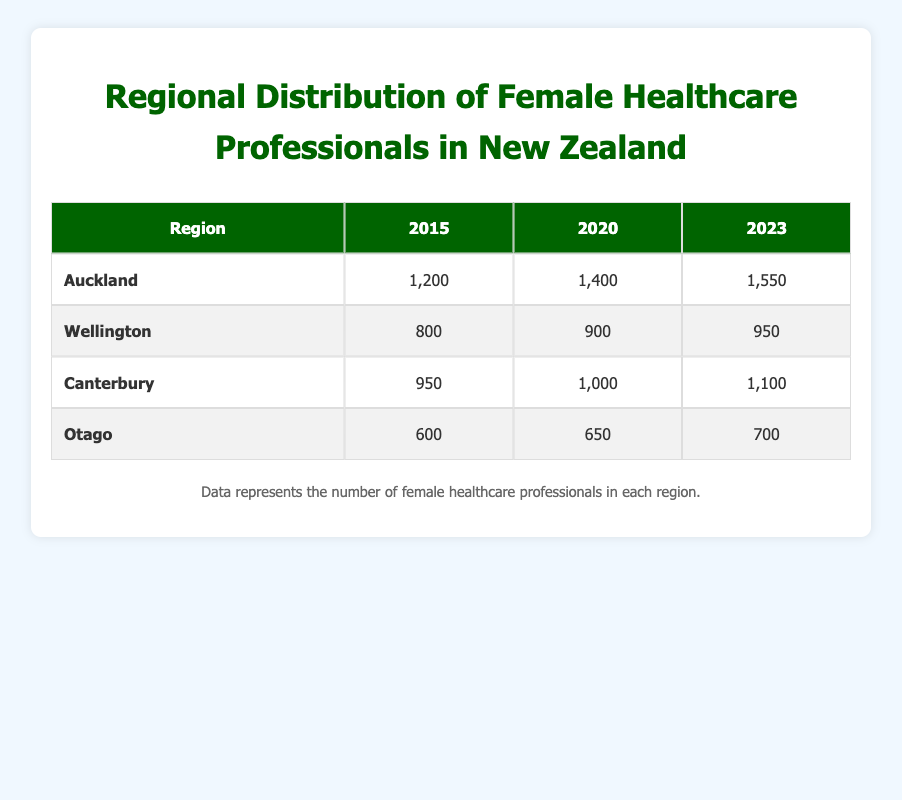What is the number of female healthcare professionals in Auckland in 2020? According to the table, the number of female healthcare professionals in Auckland for the year 2020 is listed under the column for that year. It shows a value of 1400.
Answer: 1400 How many female healthcare professionals were there in Otago in 2015? The table clearly states that for the year 2015, the value for female healthcare professionals in Otago is directly visible and is 600.
Answer: 600 Which region had the highest number of female healthcare professionals in 2023? By comparing the values in the 2023 column across all regions, Auckland has the highest value at 1550, which exceeds the numbers given for Wellington, Canterbury, and Otago.
Answer: Auckland What was the difference in the number of female healthcare professionals in Wellington from 2015 to 2023? The value for Wellington in 2015 is 800 and in 2023 it is 950. The difference can be calculated by subtracting 800 from 950, giving 150.
Answer: 150 Is it true that Canterbury had more female healthcare professionals than Otago in 2020? In the table for 2020, Canterbury shows 1000 female healthcare professionals while Otago has 650. Since 1000 is greater than 650, the statement is true.
Answer: Yes What is the average number of female healthcare professionals across all regions in 2015? To find the average, add the values for all regions in 2015: 1200 (Auckland) + 800 (Wellington) + 950 (Canterbury) + 600 (Otago) = 1550. There are 4 regions, so we divide 1550 by 4 to get the average: 1550 / 4 = 387.5.
Answer: 387.5 How many more female healthcare professionals were in Auckland in 2023 compared to 2015? The number of female healthcare professionals in Auckland is 1550 in 2023 and was 1200 in 2015. The difference is calculated as 1550 - 1200 = 350.
Answer: 350 Is the total number of female healthcare professionals in Wellington across all years (2015, 2020, 2023) greater than 3000? The total can be calculated as 800 (2015) + 900 (2020) + 950 (2023) = 2650, which is less than 3000. Therefore, the statement is false.
Answer: No In which year did Otago have the largest percentage increase in female healthcare professionals compared to the previous measurement? Calculating the percentage increases: from 2015 to 2020, Otago went from 600 to 650, a change of about 8.33%. From 2020 to 2023, it increased from 650 to 700, a change of about 7.69%. The largest percentage increase was from 2015 to 2020.
Answer: 2015 to 2020 